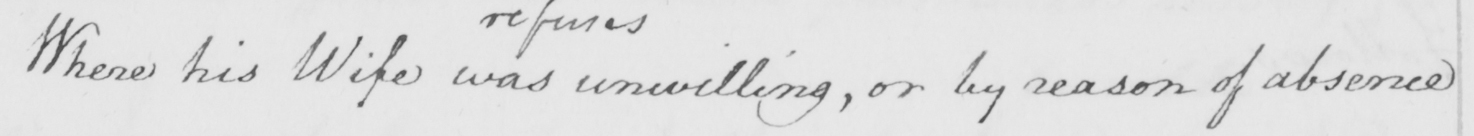What does this handwritten line say? Where his Wife was unwilling , or by reason of absence 